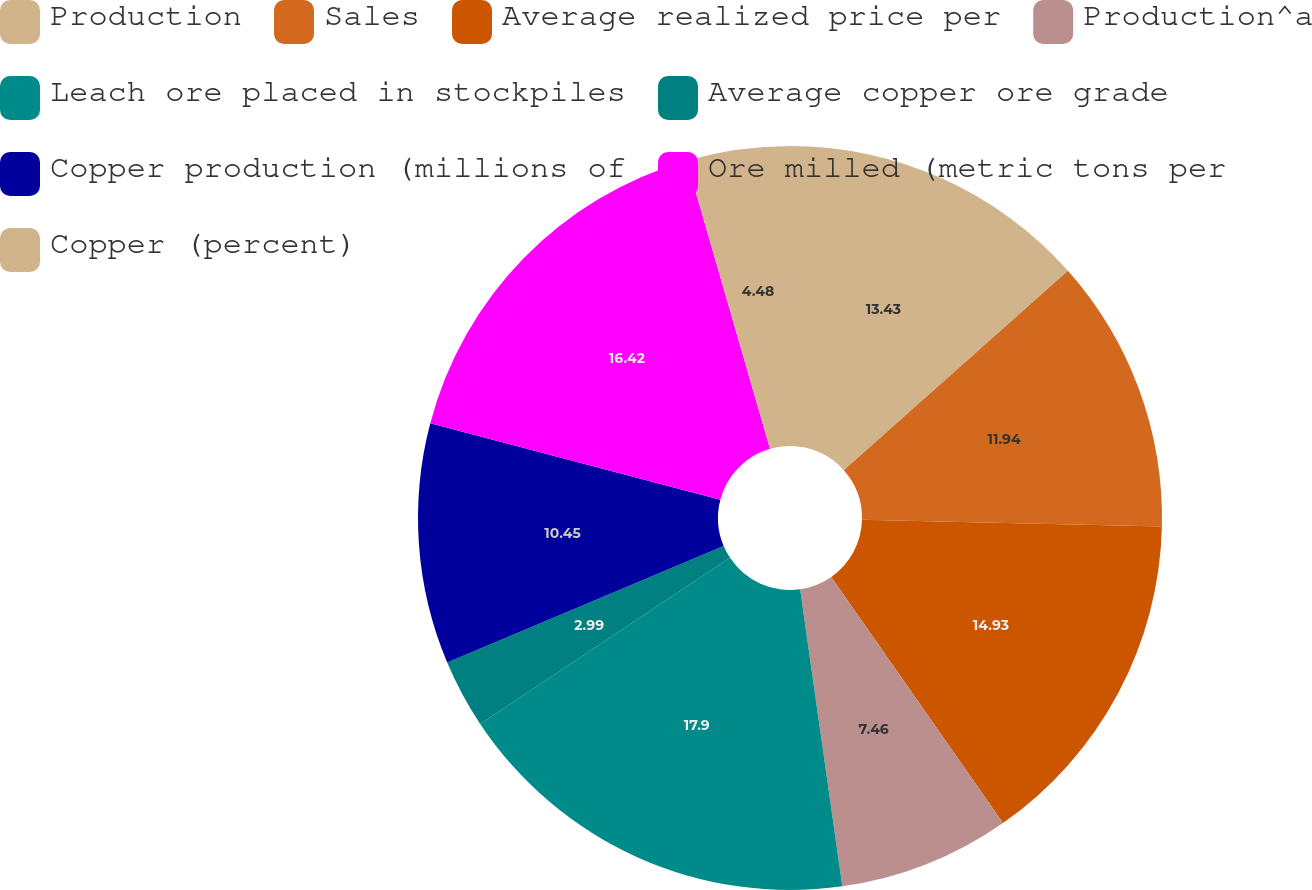<chart> <loc_0><loc_0><loc_500><loc_500><pie_chart><fcel>Production<fcel>Sales<fcel>Average realized price per<fcel>Production^a<fcel>Leach ore placed in stockpiles<fcel>Average copper ore grade<fcel>Copper production (millions of<fcel>Ore milled (metric tons per<fcel>Copper (percent)<nl><fcel>13.43%<fcel>11.94%<fcel>14.93%<fcel>7.46%<fcel>17.91%<fcel>2.99%<fcel>10.45%<fcel>16.42%<fcel>4.48%<nl></chart> 